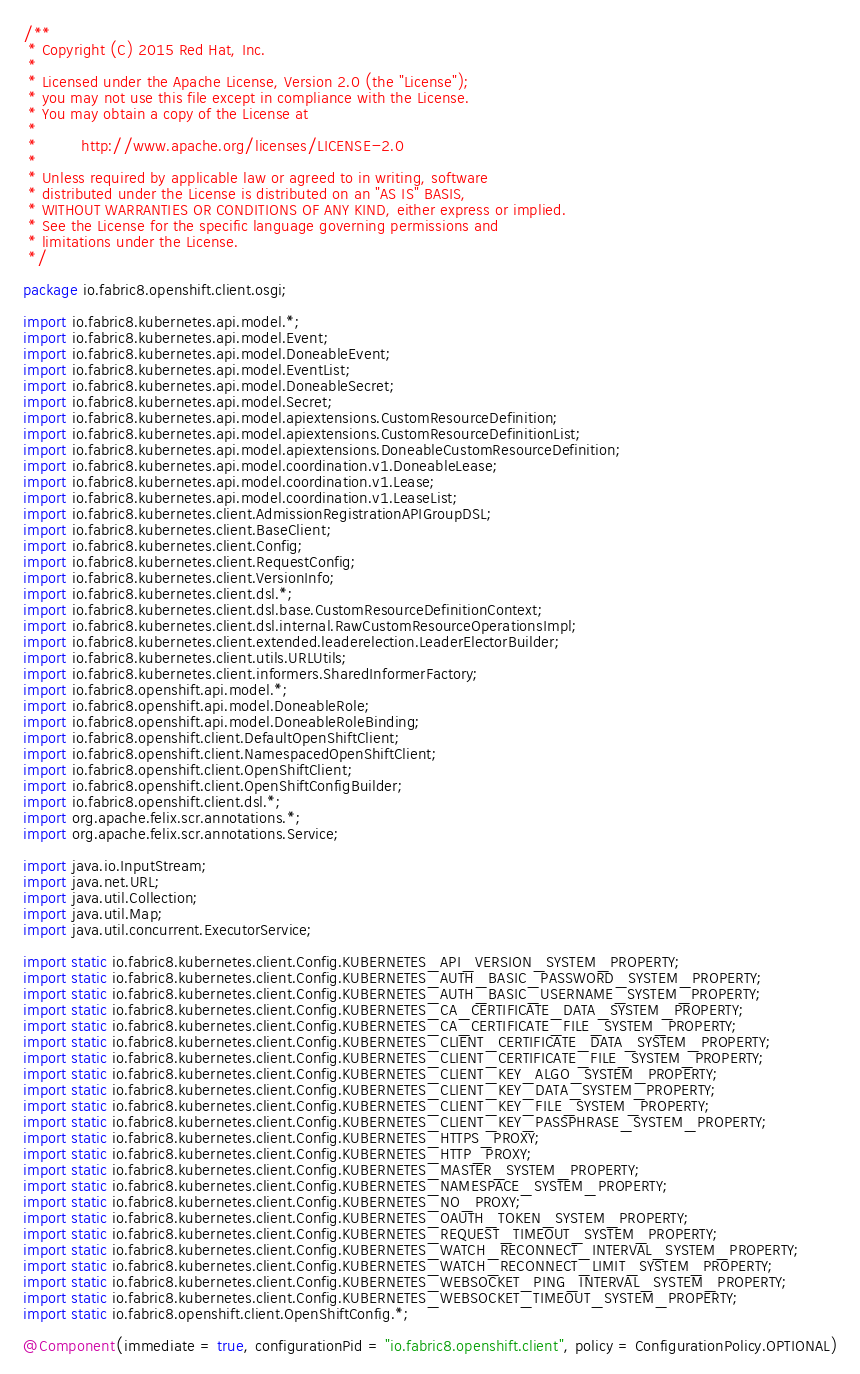Convert code to text. <code><loc_0><loc_0><loc_500><loc_500><_Java_>/**
 * Copyright (C) 2015 Red Hat, Inc.
 *
 * Licensed under the Apache License, Version 2.0 (the "License");
 * you may not use this file except in compliance with the License.
 * You may obtain a copy of the License at
 *
 *         http://www.apache.org/licenses/LICENSE-2.0
 *
 * Unless required by applicable law or agreed to in writing, software
 * distributed under the License is distributed on an "AS IS" BASIS,
 * WITHOUT WARRANTIES OR CONDITIONS OF ANY KIND, either express or implied.
 * See the License for the specific language governing permissions and
 * limitations under the License.
 */

package io.fabric8.openshift.client.osgi;

import io.fabric8.kubernetes.api.model.*;
import io.fabric8.kubernetes.api.model.Event;
import io.fabric8.kubernetes.api.model.DoneableEvent;
import io.fabric8.kubernetes.api.model.EventList;
import io.fabric8.kubernetes.api.model.DoneableSecret;
import io.fabric8.kubernetes.api.model.Secret;
import io.fabric8.kubernetes.api.model.apiextensions.CustomResourceDefinition;
import io.fabric8.kubernetes.api.model.apiextensions.CustomResourceDefinitionList;
import io.fabric8.kubernetes.api.model.apiextensions.DoneableCustomResourceDefinition;
import io.fabric8.kubernetes.api.model.coordination.v1.DoneableLease;
import io.fabric8.kubernetes.api.model.coordination.v1.Lease;
import io.fabric8.kubernetes.api.model.coordination.v1.LeaseList;
import io.fabric8.kubernetes.client.AdmissionRegistrationAPIGroupDSL;
import io.fabric8.kubernetes.client.BaseClient;
import io.fabric8.kubernetes.client.Config;
import io.fabric8.kubernetes.client.RequestConfig;
import io.fabric8.kubernetes.client.VersionInfo;
import io.fabric8.kubernetes.client.dsl.*;
import io.fabric8.kubernetes.client.dsl.base.CustomResourceDefinitionContext;
import io.fabric8.kubernetes.client.dsl.internal.RawCustomResourceOperationsImpl;
import io.fabric8.kubernetes.client.extended.leaderelection.LeaderElectorBuilder;
import io.fabric8.kubernetes.client.utils.URLUtils;
import io.fabric8.kubernetes.client.informers.SharedInformerFactory;
import io.fabric8.openshift.api.model.*;
import io.fabric8.openshift.api.model.DoneableRole;
import io.fabric8.openshift.api.model.DoneableRoleBinding;
import io.fabric8.openshift.client.DefaultOpenShiftClient;
import io.fabric8.openshift.client.NamespacedOpenShiftClient;
import io.fabric8.openshift.client.OpenShiftClient;
import io.fabric8.openshift.client.OpenShiftConfigBuilder;
import io.fabric8.openshift.client.dsl.*;
import org.apache.felix.scr.annotations.*;
import org.apache.felix.scr.annotations.Service;

import java.io.InputStream;
import java.net.URL;
import java.util.Collection;
import java.util.Map;
import java.util.concurrent.ExecutorService;

import static io.fabric8.kubernetes.client.Config.KUBERNETES_API_VERSION_SYSTEM_PROPERTY;
import static io.fabric8.kubernetes.client.Config.KUBERNETES_AUTH_BASIC_PASSWORD_SYSTEM_PROPERTY;
import static io.fabric8.kubernetes.client.Config.KUBERNETES_AUTH_BASIC_USERNAME_SYSTEM_PROPERTY;
import static io.fabric8.kubernetes.client.Config.KUBERNETES_CA_CERTIFICATE_DATA_SYSTEM_PROPERTY;
import static io.fabric8.kubernetes.client.Config.KUBERNETES_CA_CERTIFICATE_FILE_SYSTEM_PROPERTY;
import static io.fabric8.kubernetes.client.Config.KUBERNETES_CLIENT_CERTIFICATE_DATA_SYSTEM_PROPERTY;
import static io.fabric8.kubernetes.client.Config.KUBERNETES_CLIENT_CERTIFICATE_FILE_SYSTEM_PROPERTY;
import static io.fabric8.kubernetes.client.Config.KUBERNETES_CLIENT_KEY_ALGO_SYSTEM_PROPERTY;
import static io.fabric8.kubernetes.client.Config.KUBERNETES_CLIENT_KEY_DATA_SYSTEM_PROPERTY;
import static io.fabric8.kubernetes.client.Config.KUBERNETES_CLIENT_KEY_FILE_SYSTEM_PROPERTY;
import static io.fabric8.kubernetes.client.Config.KUBERNETES_CLIENT_KEY_PASSPHRASE_SYSTEM_PROPERTY;
import static io.fabric8.kubernetes.client.Config.KUBERNETES_HTTPS_PROXY;
import static io.fabric8.kubernetes.client.Config.KUBERNETES_HTTP_PROXY;
import static io.fabric8.kubernetes.client.Config.KUBERNETES_MASTER_SYSTEM_PROPERTY;
import static io.fabric8.kubernetes.client.Config.KUBERNETES_NAMESPACE_SYSTEM_PROPERTY;
import static io.fabric8.kubernetes.client.Config.KUBERNETES_NO_PROXY;
import static io.fabric8.kubernetes.client.Config.KUBERNETES_OAUTH_TOKEN_SYSTEM_PROPERTY;
import static io.fabric8.kubernetes.client.Config.KUBERNETES_REQUEST_TIMEOUT_SYSTEM_PROPERTY;
import static io.fabric8.kubernetes.client.Config.KUBERNETES_WATCH_RECONNECT_INTERVAL_SYSTEM_PROPERTY;
import static io.fabric8.kubernetes.client.Config.KUBERNETES_WATCH_RECONNECT_LIMIT_SYSTEM_PROPERTY;
import static io.fabric8.kubernetes.client.Config.KUBERNETES_WEBSOCKET_PING_INTERVAL_SYSTEM_PROPERTY;
import static io.fabric8.kubernetes.client.Config.KUBERNETES_WEBSOCKET_TIMEOUT_SYSTEM_PROPERTY;
import static io.fabric8.openshift.client.OpenShiftConfig.*;

@Component(immediate = true, configurationPid = "io.fabric8.openshift.client", policy = ConfigurationPolicy.OPTIONAL)</code> 